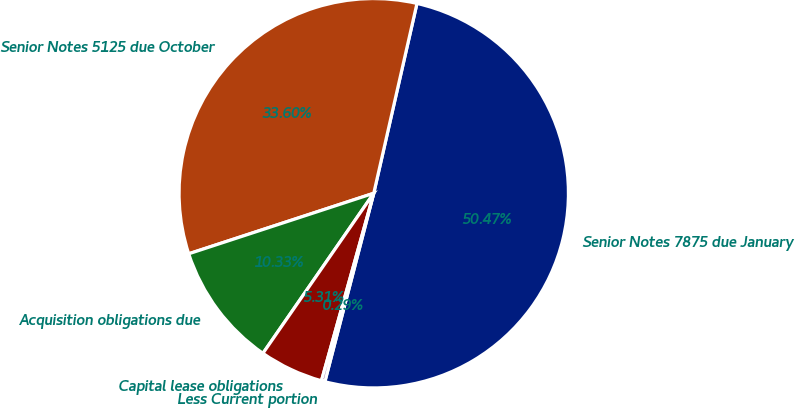Convert chart. <chart><loc_0><loc_0><loc_500><loc_500><pie_chart><fcel>Senior Notes 7875 due January<fcel>Senior Notes 5125 due October<fcel>Acquisition obligations due<fcel>Capital lease obligations<fcel>Less Current portion<nl><fcel>50.48%<fcel>33.6%<fcel>10.33%<fcel>5.31%<fcel>0.29%<nl></chart> 